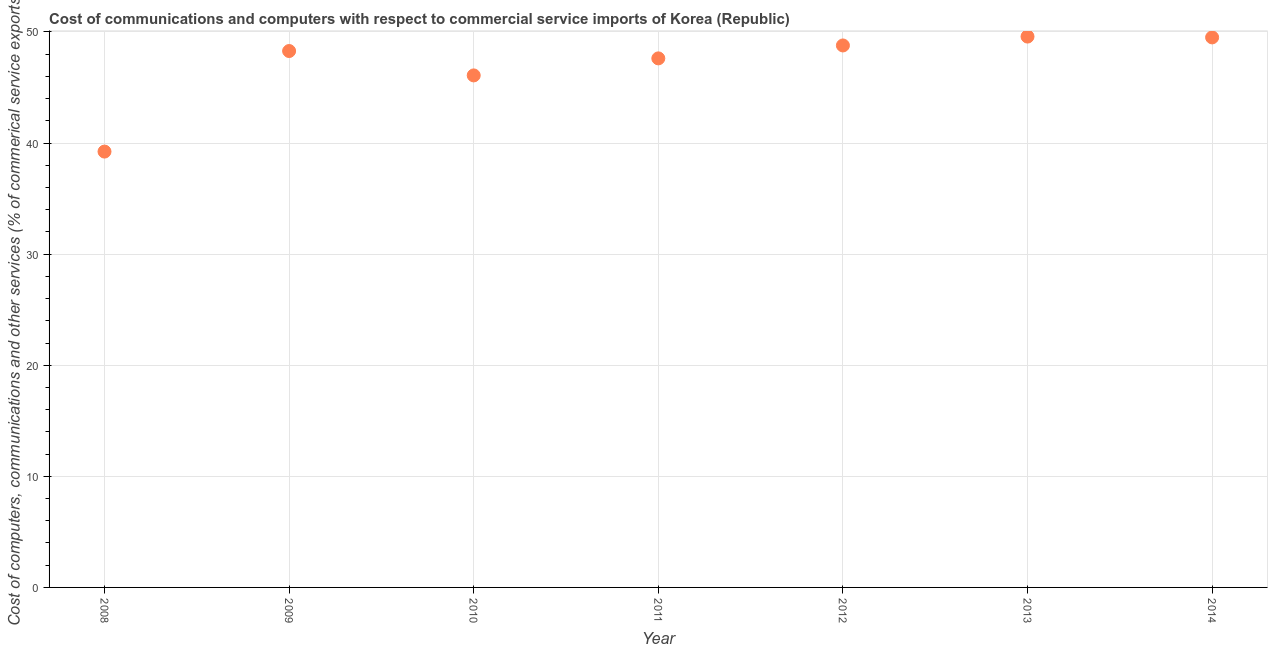What is the cost of communications in 2011?
Your answer should be very brief. 47.62. Across all years, what is the maximum cost of communications?
Offer a very short reply. 49.59. Across all years, what is the minimum  computer and other services?
Your answer should be compact. 39.23. In which year was the cost of communications minimum?
Your answer should be compact. 2008. What is the sum of the cost of communications?
Provide a succinct answer. 329.11. What is the difference between the  computer and other services in 2009 and 2011?
Ensure brevity in your answer.  0.66. What is the average  computer and other services per year?
Ensure brevity in your answer.  47.02. What is the median  computer and other services?
Provide a succinct answer. 48.28. Do a majority of the years between 2012 and 2011 (inclusive) have  computer and other services greater than 36 %?
Keep it short and to the point. No. What is the ratio of the  computer and other services in 2008 to that in 2010?
Make the answer very short. 0.85. Is the  computer and other services in 2011 less than that in 2013?
Your answer should be compact. Yes. Is the difference between the cost of communications in 2008 and 2010 greater than the difference between any two years?
Provide a succinct answer. No. What is the difference between the highest and the second highest  computer and other services?
Provide a succinct answer. 0.07. Is the sum of the cost of communications in 2009 and 2011 greater than the maximum cost of communications across all years?
Keep it short and to the point. Yes. What is the difference between the highest and the lowest cost of communications?
Your answer should be very brief. 10.35. In how many years, is the cost of communications greater than the average cost of communications taken over all years?
Ensure brevity in your answer.  5. Does the  computer and other services monotonically increase over the years?
Offer a very short reply. No. How many years are there in the graph?
Make the answer very short. 7. Does the graph contain grids?
Ensure brevity in your answer.  Yes. What is the title of the graph?
Give a very brief answer. Cost of communications and computers with respect to commercial service imports of Korea (Republic). What is the label or title of the X-axis?
Offer a terse response. Year. What is the label or title of the Y-axis?
Provide a short and direct response. Cost of computers, communications and other services (% of commerical service exports). What is the Cost of computers, communications and other services (% of commerical service exports) in 2008?
Ensure brevity in your answer.  39.23. What is the Cost of computers, communications and other services (% of commerical service exports) in 2009?
Give a very brief answer. 48.28. What is the Cost of computers, communications and other services (% of commerical service exports) in 2010?
Your response must be concise. 46.09. What is the Cost of computers, communications and other services (% of commerical service exports) in 2011?
Offer a terse response. 47.62. What is the Cost of computers, communications and other services (% of commerical service exports) in 2012?
Provide a succinct answer. 48.79. What is the Cost of computers, communications and other services (% of commerical service exports) in 2013?
Provide a short and direct response. 49.59. What is the Cost of computers, communications and other services (% of commerical service exports) in 2014?
Provide a short and direct response. 49.51. What is the difference between the Cost of computers, communications and other services (% of commerical service exports) in 2008 and 2009?
Offer a very short reply. -9.05. What is the difference between the Cost of computers, communications and other services (% of commerical service exports) in 2008 and 2010?
Give a very brief answer. -6.86. What is the difference between the Cost of computers, communications and other services (% of commerical service exports) in 2008 and 2011?
Your answer should be compact. -8.39. What is the difference between the Cost of computers, communications and other services (% of commerical service exports) in 2008 and 2012?
Provide a succinct answer. -9.55. What is the difference between the Cost of computers, communications and other services (% of commerical service exports) in 2008 and 2013?
Offer a terse response. -10.35. What is the difference between the Cost of computers, communications and other services (% of commerical service exports) in 2008 and 2014?
Ensure brevity in your answer.  -10.28. What is the difference between the Cost of computers, communications and other services (% of commerical service exports) in 2009 and 2010?
Your answer should be very brief. 2.19. What is the difference between the Cost of computers, communications and other services (% of commerical service exports) in 2009 and 2011?
Give a very brief answer. 0.66. What is the difference between the Cost of computers, communications and other services (% of commerical service exports) in 2009 and 2012?
Offer a terse response. -0.5. What is the difference between the Cost of computers, communications and other services (% of commerical service exports) in 2009 and 2013?
Make the answer very short. -1.3. What is the difference between the Cost of computers, communications and other services (% of commerical service exports) in 2009 and 2014?
Offer a very short reply. -1.23. What is the difference between the Cost of computers, communications and other services (% of commerical service exports) in 2010 and 2011?
Make the answer very short. -1.53. What is the difference between the Cost of computers, communications and other services (% of commerical service exports) in 2010 and 2012?
Your answer should be very brief. -2.7. What is the difference between the Cost of computers, communications and other services (% of commerical service exports) in 2010 and 2013?
Provide a short and direct response. -3.5. What is the difference between the Cost of computers, communications and other services (% of commerical service exports) in 2010 and 2014?
Your answer should be compact. -3.42. What is the difference between the Cost of computers, communications and other services (% of commerical service exports) in 2011 and 2012?
Your answer should be compact. -1.16. What is the difference between the Cost of computers, communications and other services (% of commerical service exports) in 2011 and 2013?
Make the answer very short. -1.96. What is the difference between the Cost of computers, communications and other services (% of commerical service exports) in 2011 and 2014?
Your answer should be compact. -1.89. What is the difference between the Cost of computers, communications and other services (% of commerical service exports) in 2012 and 2013?
Provide a short and direct response. -0.8. What is the difference between the Cost of computers, communications and other services (% of commerical service exports) in 2012 and 2014?
Your answer should be very brief. -0.73. What is the difference between the Cost of computers, communications and other services (% of commerical service exports) in 2013 and 2014?
Your answer should be very brief. 0.07. What is the ratio of the Cost of computers, communications and other services (% of commerical service exports) in 2008 to that in 2009?
Keep it short and to the point. 0.81. What is the ratio of the Cost of computers, communications and other services (% of commerical service exports) in 2008 to that in 2010?
Make the answer very short. 0.85. What is the ratio of the Cost of computers, communications and other services (% of commerical service exports) in 2008 to that in 2011?
Make the answer very short. 0.82. What is the ratio of the Cost of computers, communications and other services (% of commerical service exports) in 2008 to that in 2012?
Your answer should be very brief. 0.8. What is the ratio of the Cost of computers, communications and other services (% of commerical service exports) in 2008 to that in 2013?
Make the answer very short. 0.79. What is the ratio of the Cost of computers, communications and other services (% of commerical service exports) in 2008 to that in 2014?
Give a very brief answer. 0.79. What is the ratio of the Cost of computers, communications and other services (% of commerical service exports) in 2009 to that in 2010?
Provide a succinct answer. 1.05. What is the ratio of the Cost of computers, communications and other services (% of commerical service exports) in 2009 to that in 2012?
Your answer should be very brief. 0.99. What is the ratio of the Cost of computers, communications and other services (% of commerical service exports) in 2009 to that in 2013?
Offer a very short reply. 0.97. What is the ratio of the Cost of computers, communications and other services (% of commerical service exports) in 2010 to that in 2012?
Your response must be concise. 0.94. What is the ratio of the Cost of computers, communications and other services (% of commerical service exports) in 2010 to that in 2013?
Offer a very short reply. 0.93. What is the ratio of the Cost of computers, communications and other services (% of commerical service exports) in 2011 to that in 2012?
Make the answer very short. 0.98. What is the ratio of the Cost of computers, communications and other services (% of commerical service exports) in 2011 to that in 2014?
Your answer should be very brief. 0.96. What is the ratio of the Cost of computers, communications and other services (% of commerical service exports) in 2012 to that in 2013?
Offer a terse response. 0.98. What is the ratio of the Cost of computers, communications and other services (% of commerical service exports) in 2012 to that in 2014?
Provide a short and direct response. 0.98. What is the ratio of the Cost of computers, communications and other services (% of commerical service exports) in 2013 to that in 2014?
Give a very brief answer. 1. 